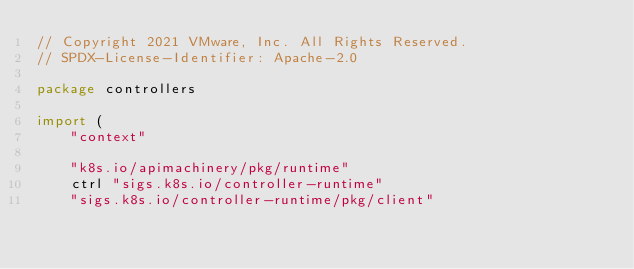Convert code to text. <code><loc_0><loc_0><loc_500><loc_500><_Go_>// Copyright 2021 VMware, Inc. All Rights Reserved.
// SPDX-License-Identifier: Apache-2.0

package controllers

import (
	"context"

	"k8s.io/apimachinery/pkg/runtime"
	ctrl "sigs.k8s.io/controller-runtime"
	"sigs.k8s.io/controller-runtime/pkg/client"</code> 